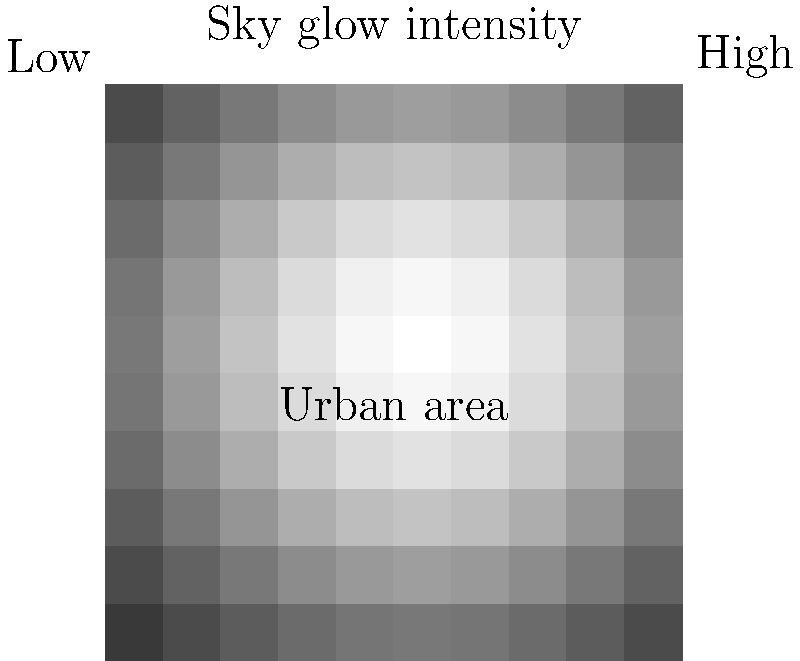Based on the sky glow map shown, which depicts light pollution intensity around an urban area, how might the circadian rhythms of nocturnal animals in the surrounding ecosystem be affected? To answer this question, we need to consider the following steps:

1. Interpret the sky glow map:
   - The map shows a gradient of light pollution intensity, with the highest levels (brightest areas) at the center, representing the urban area.
   - The intensity decreases as we move away from the center, indicated by darker shades.

2. Understand circadian rhythms:
   - Circadian rhythms are internal biological clocks that regulate various physiological processes in living organisms, including sleep-wake cycles, hormone production, and feeding patterns.
   - These rhythms are typically synchronized with the natural light-dark cycle of day and night.

3. Consider the impact of light pollution on nocturnal animals:
   - Nocturnal animals have evolved to be active during the night and rest during the day.
   - Their circadian rhythms are adapted to natural darkness at night.

4. Analyze the effects of artificial light on circadian rhythms:
   - Exposure to artificial light at night can disrupt the natural light-dark cycle that nocturnal animals depend on.
   - This disruption can lead to alterations in their circadian rhythms, affecting various biological processes.

5. Evaluate the spatial extent of the impact:
   - The sky glow map shows that light pollution extends beyond the urban center, potentially affecting a larger area of wildlife habitat.
   - Animals in areas closer to the urban center (brighter regions) are likely to experience more significant disruptions to their circadian rhythms.

6. Consider potential consequences:
   - Disrupted circadian rhythms can lead to changes in nocturnal animals' behavior, including:
     a. Altered feeding patterns
     b. Reduced reproductive success
     c. Changes in predator-prey interactions
     d. Modifications in habitat use and movement patterns

Given these factors, nocturnal animals in the ecosystem surrounding the urban area are likely to experience significant disruptions to their circadian rhythms, with the severity of the impact decreasing as distance from the urban center increases.
Answer: Significant disruption, decreasing with distance from urban center 